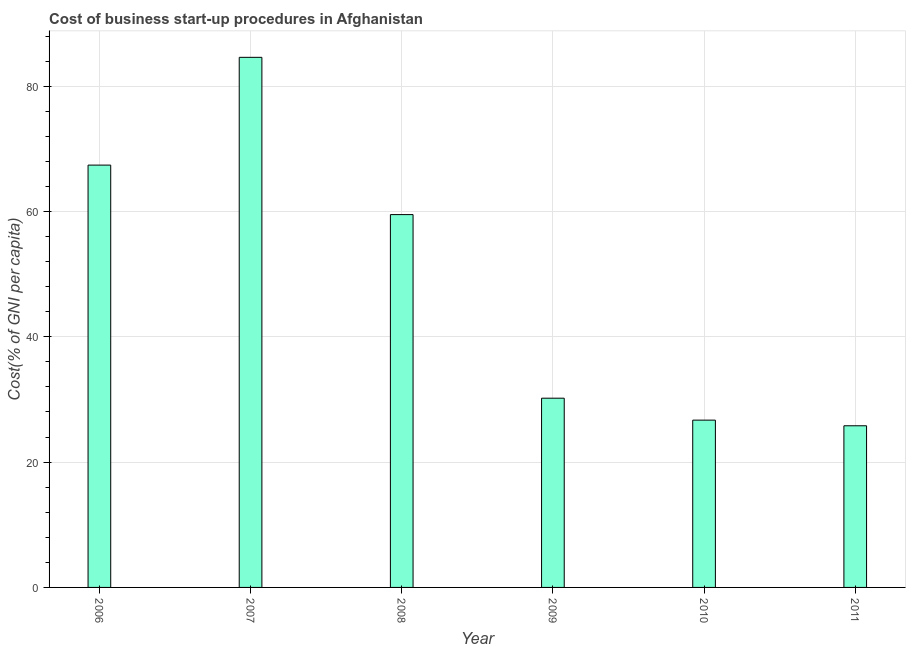Does the graph contain any zero values?
Provide a succinct answer. No. Does the graph contain grids?
Provide a succinct answer. Yes. What is the title of the graph?
Keep it short and to the point. Cost of business start-up procedures in Afghanistan. What is the label or title of the Y-axis?
Provide a succinct answer. Cost(% of GNI per capita). What is the cost of business startup procedures in 2006?
Give a very brief answer. 67.4. Across all years, what is the maximum cost of business startup procedures?
Offer a terse response. 84.6. Across all years, what is the minimum cost of business startup procedures?
Ensure brevity in your answer.  25.8. In which year was the cost of business startup procedures minimum?
Your response must be concise. 2011. What is the sum of the cost of business startup procedures?
Provide a succinct answer. 294.2. What is the average cost of business startup procedures per year?
Your answer should be very brief. 49.03. What is the median cost of business startup procedures?
Keep it short and to the point. 44.85. Do a majority of the years between 2008 and 2010 (inclusive) have cost of business startup procedures greater than 4 %?
Your answer should be compact. Yes. What is the ratio of the cost of business startup procedures in 2007 to that in 2009?
Your answer should be very brief. 2.8. Is the cost of business startup procedures in 2006 less than that in 2010?
Give a very brief answer. No. Is the difference between the cost of business startup procedures in 2007 and 2008 greater than the difference between any two years?
Provide a short and direct response. No. What is the difference between the highest and the lowest cost of business startup procedures?
Your response must be concise. 58.8. In how many years, is the cost of business startup procedures greater than the average cost of business startup procedures taken over all years?
Your response must be concise. 3. Are all the bars in the graph horizontal?
Provide a short and direct response. No. What is the difference between two consecutive major ticks on the Y-axis?
Offer a terse response. 20. What is the Cost(% of GNI per capita) of 2006?
Give a very brief answer. 67.4. What is the Cost(% of GNI per capita) in 2007?
Your response must be concise. 84.6. What is the Cost(% of GNI per capita) of 2008?
Your answer should be compact. 59.5. What is the Cost(% of GNI per capita) of 2009?
Offer a very short reply. 30.2. What is the Cost(% of GNI per capita) of 2010?
Your response must be concise. 26.7. What is the Cost(% of GNI per capita) in 2011?
Provide a short and direct response. 25.8. What is the difference between the Cost(% of GNI per capita) in 2006 and 2007?
Ensure brevity in your answer.  -17.2. What is the difference between the Cost(% of GNI per capita) in 2006 and 2008?
Ensure brevity in your answer.  7.9. What is the difference between the Cost(% of GNI per capita) in 2006 and 2009?
Your answer should be compact. 37.2. What is the difference between the Cost(% of GNI per capita) in 2006 and 2010?
Offer a terse response. 40.7. What is the difference between the Cost(% of GNI per capita) in 2006 and 2011?
Ensure brevity in your answer.  41.6. What is the difference between the Cost(% of GNI per capita) in 2007 and 2008?
Your answer should be very brief. 25.1. What is the difference between the Cost(% of GNI per capita) in 2007 and 2009?
Offer a terse response. 54.4. What is the difference between the Cost(% of GNI per capita) in 2007 and 2010?
Your answer should be very brief. 57.9. What is the difference between the Cost(% of GNI per capita) in 2007 and 2011?
Provide a short and direct response. 58.8. What is the difference between the Cost(% of GNI per capita) in 2008 and 2009?
Keep it short and to the point. 29.3. What is the difference between the Cost(% of GNI per capita) in 2008 and 2010?
Your answer should be compact. 32.8. What is the difference between the Cost(% of GNI per capita) in 2008 and 2011?
Your answer should be very brief. 33.7. What is the difference between the Cost(% of GNI per capita) in 2009 and 2010?
Offer a terse response. 3.5. What is the difference between the Cost(% of GNI per capita) in 2009 and 2011?
Your response must be concise. 4.4. What is the difference between the Cost(% of GNI per capita) in 2010 and 2011?
Keep it short and to the point. 0.9. What is the ratio of the Cost(% of GNI per capita) in 2006 to that in 2007?
Ensure brevity in your answer.  0.8. What is the ratio of the Cost(% of GNI per capita) in 2006 to that in 2008?
Your answer should be very brief. 1.13. What is the ratio of the Cost(% of GNI per capita) in 2006 to that in 2009?
Offer a terse response. 2.23. What is the ratio of the Cost(% of GNI per capita) in 2006 to that in 2010?
Your answer should be very brief. 2.52. What is the ratio of the Cost(% of GNI per capita) in 2006 to that in 2011?
Your answer should be compact. 2.61. What is the ratio of the Cost(% of GNI per capita) in 2007 to that in 2008?
Provide a short and direct response. 1.42. What is the ratio of the Cost(% of GNI per capita) in 2007 to that in 2009?
Your answer should be very brief. 2.8. What is the ratio of the Cost(% of GNI per capita) in 2007 to that in 2010?
Your answer should be very brief. 3.17. What is the ratio of the Cost(% of GNI per capita) in 2007 to that in 2011?
Your answer should be compact. 3.28. What is the ratio of the Cost(% of GNI per capita) in 2008 to that in 2009?
Offer a terse response. 1.97. What is the ratio of the Cost(% of GNI per capita) in 2008 to that in 2010?
Give a very brief answer. 2.23. What is the ratio of the Cost(% of GNI per capita) in 2008 to that in 2011?
Make the answer very short. 2.31. What is the ratio of the Cost(% of GNI per capita) in 2009 to that in 2010?
Ensure brevity in your answer.  1.13. What is the ratio of the Cost(% of GNI per capita) in 2009 to that in 2011?
Offer a terse response. 1.17. What is the ratio of the Cost(% of GNI per capita) in 2010 to that in 2011?
Provide a succinct answer. 1.03. 